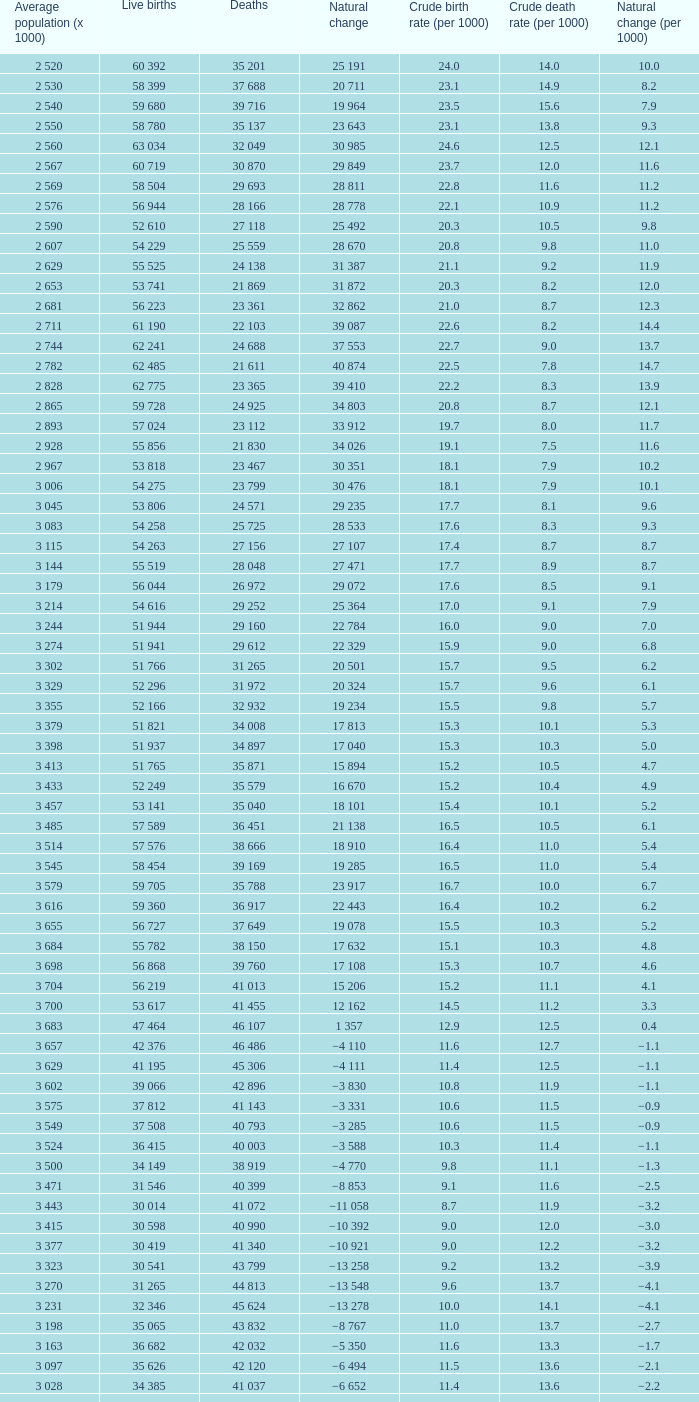Which natural variation has a crude mortality rate (per 1000) greater than 9, and 40,399 fatalities? −8 853. 